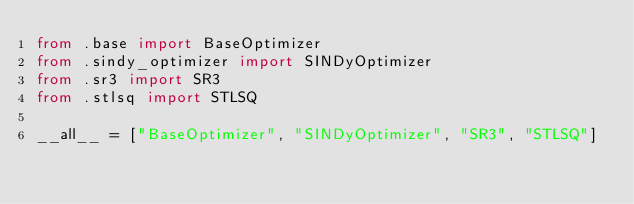<code> <loc_0><loc_0><loc_500><loc_500><_Python_>from .base import BaseOptimizer
from .sindy_optimizer import SINDyOptimizer
from .sr3 import SR3
from .stlsq import STLSQ

__all__ = ["BaseOptimizer", "SINDyOptimizer", "SR3", "STLSQ"]
</code> 